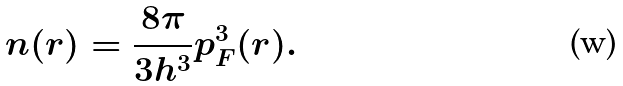<formula> <loc_0><loc_0><loc_500><loc_500>n ( r ) = { \frac { 8 \pi } { 3 h ^ { 3 } } } p _ { F } ^ { 3 } ( r ) .</formula> 